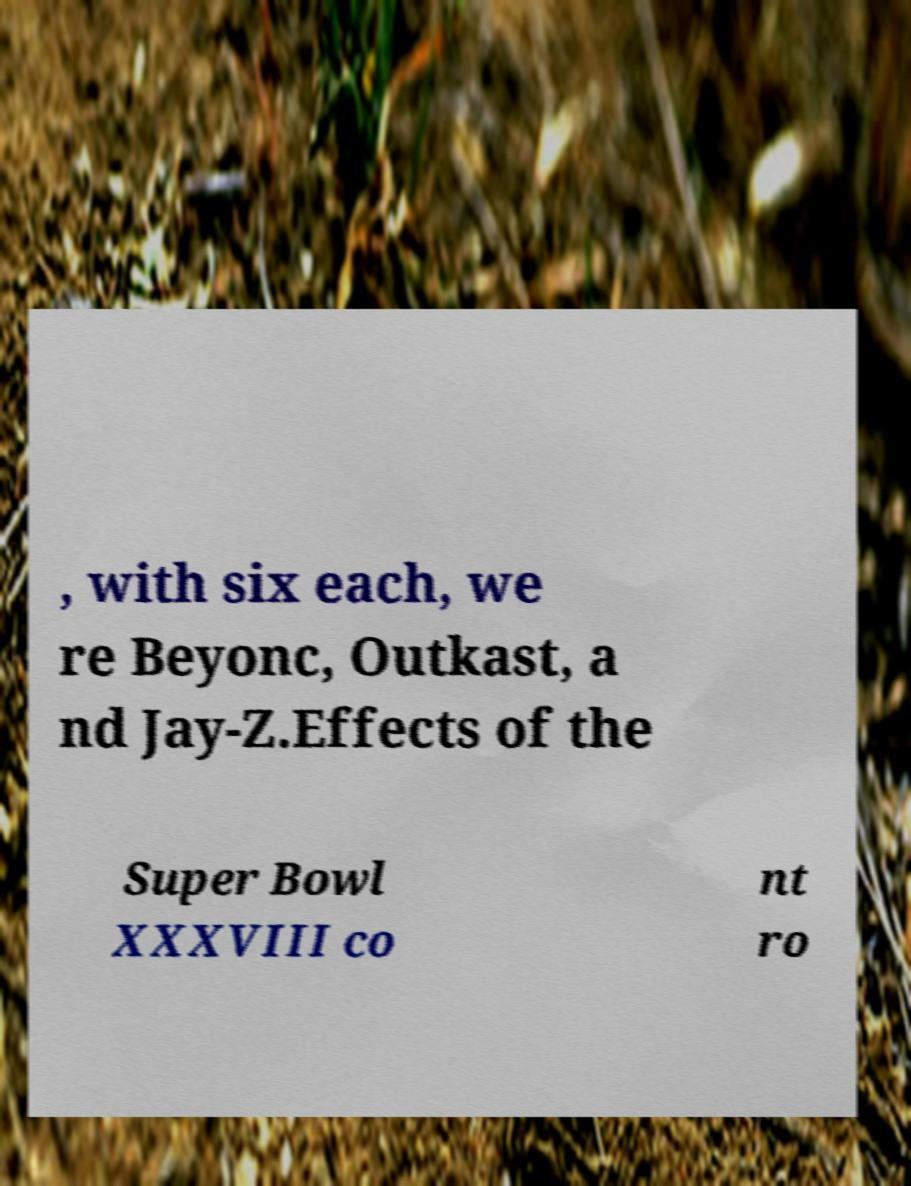Can you accurately transcribe the text from the provided image for me? , with six each, we re Beyonc, Outkast, a nd Jay-Z.Effects of the Super Bowl XXXVIII co nt ro 